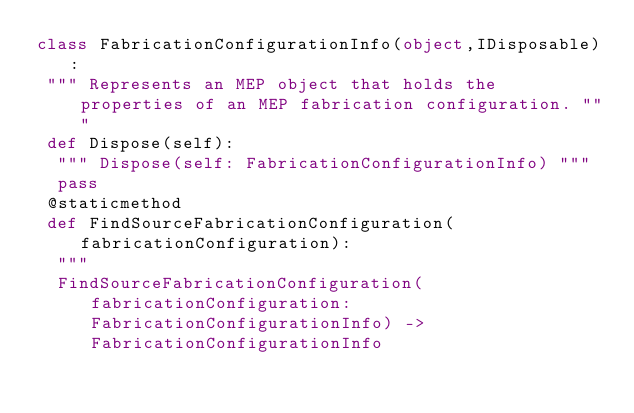<code> <loc_0><loc_0><loc_500><loc_500><_Python_>class FabricationConfigurationInfo(object,IDisposable):
 """ Represents an MEP object that holds the properties of an MEP fabrication configuration. """
 def Dispose(self):
  """ Dispose(self: FabricationConfigurationInfo) """
  pass
 @staticmethod
 def FindSourceFabricationConfiguration(fabricationConfiguration):
  """
  FindSourceFabricationConfiguration(fabricationConfiguration: FabricationConfigurationInfo) -> FabricationConfigurationInfo

  
</code> 